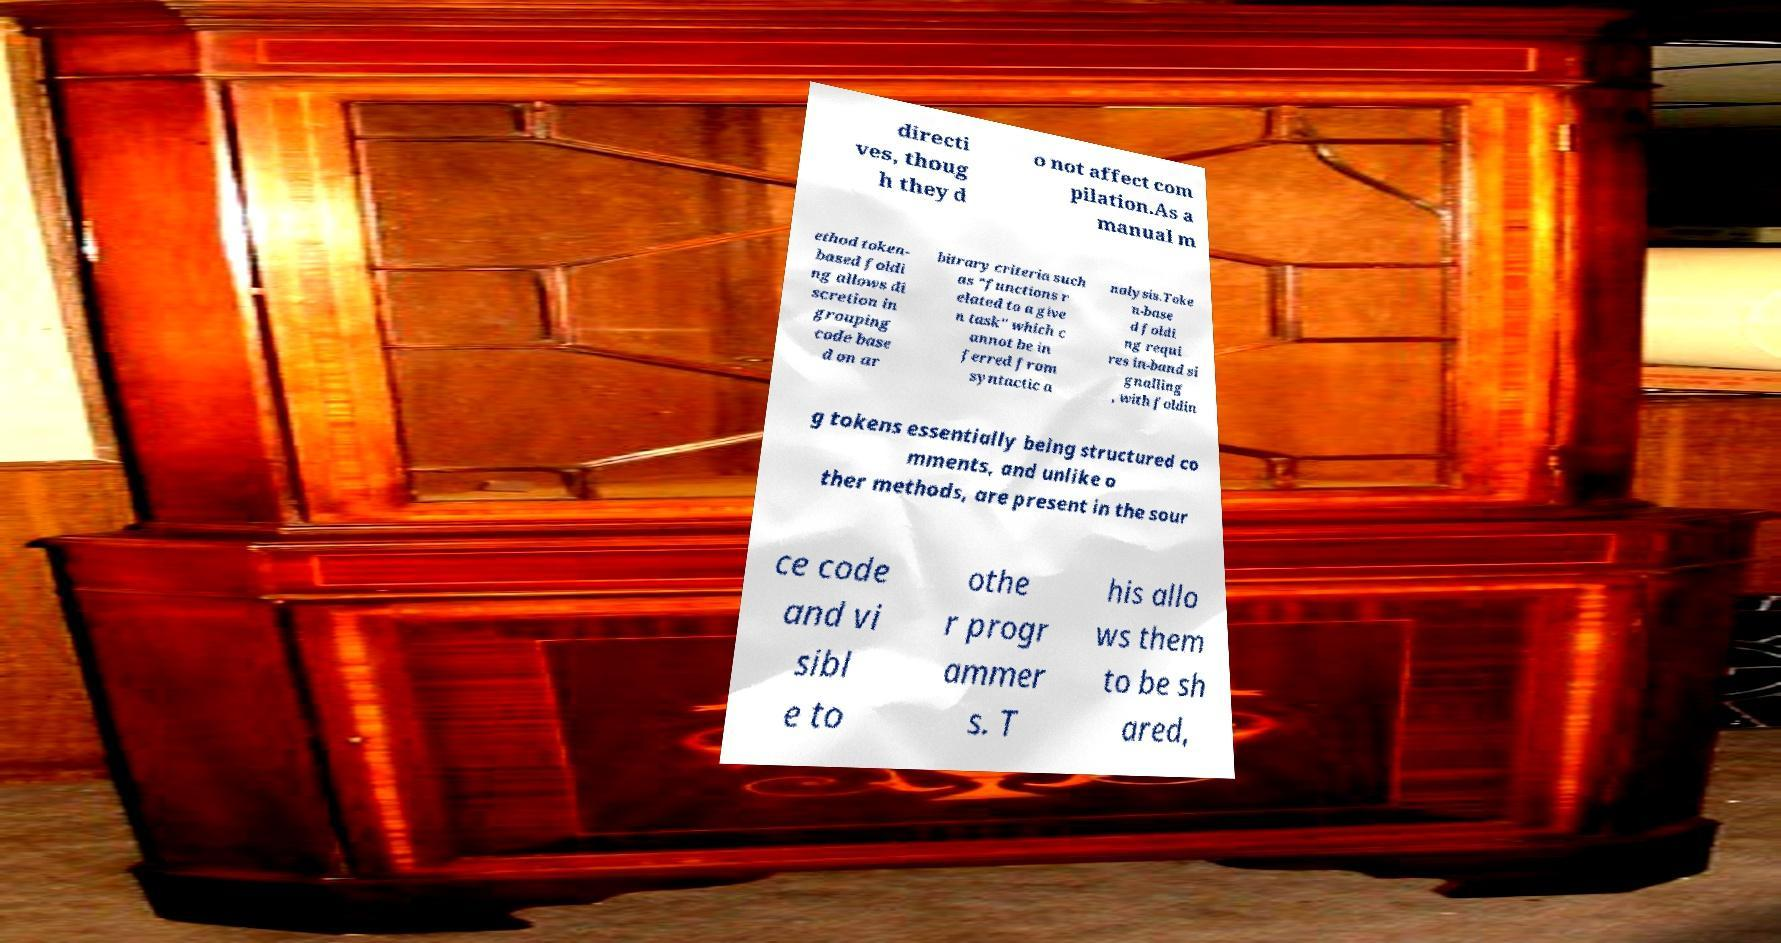What messages or text are displayed in this image? I need them in a readable, typed format. directi ves, thoug h they d o not affect com pilation.As a manual m ethod token- based foldi ng allows di scretion in grouping code base d on ar bitrary criteria such as "functions r elated to a give n task" which c annot be in ferred from syntactic a nalysis.Toke n-base d foldi ng requi res in-band si gnalling , with foldin g tokens essentially being structured co mments, and unlike o ther methods, are present in the sour ce code and vi sibl e to othe r progr ammer s. T his allo ws them to be sh ared, 